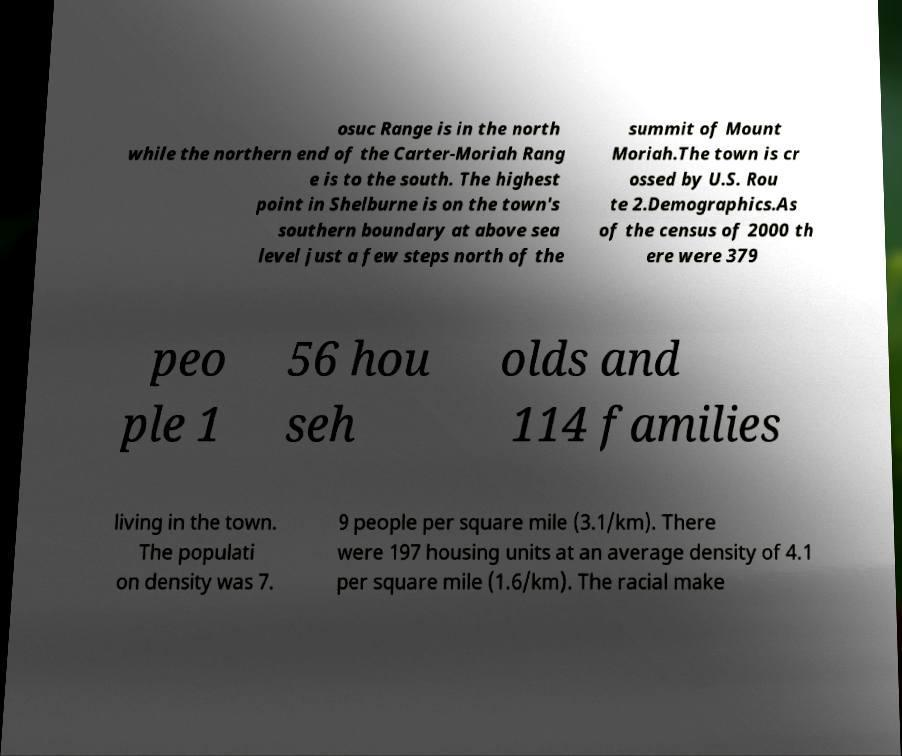Could you extract and type out the text from this image? osuc Range is in the north while the northern end of the Carter-Moriah Rang e is to the south. The highest point in Shelburne is on the town's southern boundary at above sea level just a few steps north of the summit of Mount Moriah.The town is cr ossed by U.S. Rou te 2.Demographics.As of the census of 2000 th ere were 379 peo ple 1 56 hou seh olds and 114 families living in the town. The populati on density was 7. 9 people per square mile (3.1/km). There were 197 housing units at an average density of 4.1 per square mile (1.6/km). The racial make 